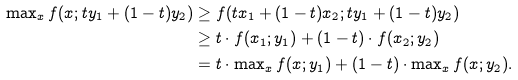<formula> <loc_0><loc_0><loc_500><loc_500>\max \nolimits _ { x } f ( x ; t y _ { 1 } + ( 1 - t ) y _ { 2 } ) & \geq f ( t x _ { 1 } + ( 1 - t ) x _ { 2 } ; t y _ { 1 } + ( 1 - t ) y _ { 2 } ) \\ & \geq t \cdot f ( x _ { 1 } ; y _ { 1 } ) + ( 1 - t ) \cdot f ( x _ { 2 } ; y _ { 2 } ) \\ & = t \cdot \max \nolimits _ { x } f ( x ; y _ { 1 } ) + ( 1 - t ) \cdot \max \nolimits _ { x } f ( x ; y _ { 2 } ) .</formula> 